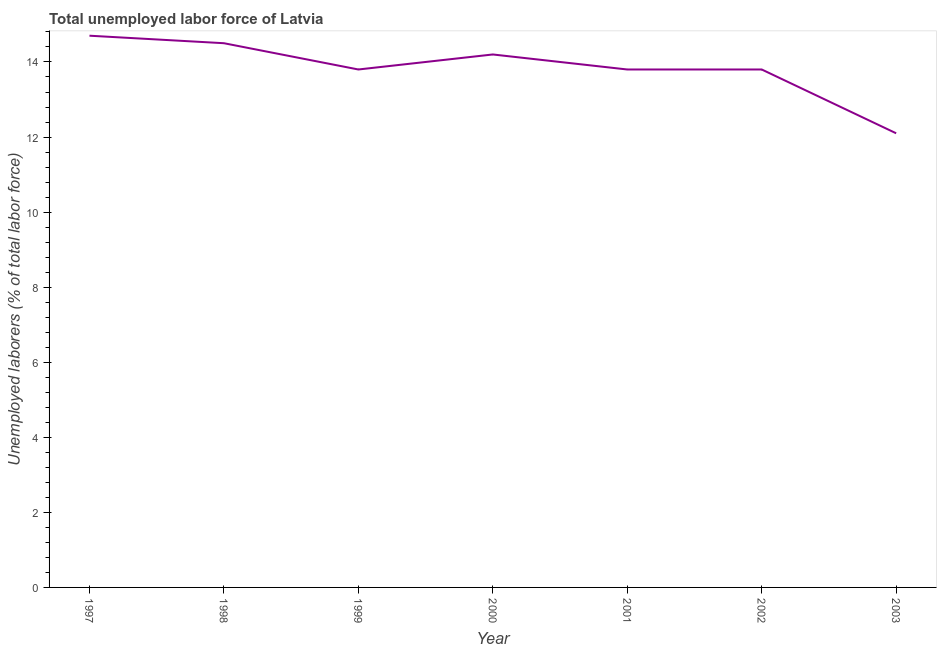What is the total unemployed labour force in 1999?
Give a very brief answer. 13.8. Across all years, what is the maximum total unemployed labour force?
Your answer should be very brief. 14.7. Across all years, what is the minimum total unemployed labour force?
Offer a terse response. 12.1. In which year was the total unemployed labour force minimum?
Your answer should be very brief. 2003. What is the sum of the total unemployed labour force?
Your answer should be very brief. 96.9. What is the difference between the total unemployed labour force in 1998 and 2003?
Offer a very short reply. 2.4. What is the average total unemployed labour force per year?
Provide a short and direct response. 13.84. What is the median total unemployed labour force?
Ensure brevity in your answer.  13.8. In how many years, is the total unemployed labour force greater than 0.4 %?
Keep it short and to the point. 7. Do a majority of the years between 2001 and 2003 (inclusive) have total unemployed labour force greater than 11.2 %?
Give a very brief answer. Yes. What is the ratio of the total unemployed labour force in 1999 to that in 2001?
Your answer should be very brief. 1. Is the total unemployed labour force in 2000 less than that in 2001?
Offer a very short reply. No. Is the difference between the total unemployed labour force in 1998 and 1999 greater than the difference between any two years?
Keep it short and to the point. No. What is the difference between the highest and the second highest total unemployed labour force?
Your response must be concise. 0.2. Is the sum of the total unemployed labour force in 2000 and 2003 greater than the maximum total unemployed labour force across all years?
Your response must be concise. Yes. What is the difference between the highest and the lowest total unemployed labour force?
Keep it short and to the point. 2.6. In how many years, is the total unemployed labour force greater than the average total unemployed labour force taken over all years?
Make the answer very short. 3. How many years are there in the graph?
Your answer should be compact. 7. What is the difference between two consecutive major ticks on the Y-axis?
Offer a terse response. 2. Does the graph contain grids?
Provide a short and direct response. No. What is the title of the graph?
Your answer should be very brief. Total unemployed labor force of Latvia. What is the label or title of the X-axis?
Offer a terse response. Year. What is the label or title of the Y-axis?
Your answer should be compact. Unemployed laborers (% of total labor force). What is the Unemployed laborers (% of total labor force) of 1997?
Offer a terse response. 14.7. What is the Unemployed laborers (% of total labor force) in 1999?
Your answer should be compact. 13.8. What is the Unemployed laborers (% of total labor force) of 2000?
Offer a very short reply. 14.2. What is the Unemployed laborers (% of total labor force) of 2001?
Make the answer very short. 13.8. What is the Unemployed laborers (% of total labor force) of 2002?
Offer a very short reply. 13.8. What is the Unemployed laborers (% of total labor force) in 2003?
Offer a terse response. 12.1. What is the difference between the Unemployed laborers (% of total labor force) in 1997 and 2003?
Offer a terse response. 2.6. What is the difference between the Unemployed laborers (% of total labor force) in 1998 and 1999?
Your answer should be compact. 0.7. What is the difference between the Unemployed laborers (% of total labor force) in 1998 and 2000?
Your answer should be very brief. 0.3. What is the difference between the Unemployed laborers (% of total labor force) in 1998 and 2002?
Your answer should be very brief. 0.7. What is the difference between the Unemployed laborers (% of total labor force) in 1998 and 2003?
Give a very brief answer. 2.4. What is the difference between the Unemployed laborers (% of total labor force) in 1999 and 2003?
Offer a very short reply. 1.7. What is the difference between the Unemployed laborers (% of total labor force) in 2000 and 2001?
Offer a terse response. 0.4. What is the difference between the Unemployed laborers (% of total labor force) in 2000 and 2002?
Offer a very short reply. 0.4. What is the difference between the Unemployed laborers (% of total labor force) in 2002 and 2003?
Ensure brevity in your answer.  1.7. What is the ratio of the Unemployed laborers (% of total labor force) in 1997 to that in 1998?
Give a very brief answer. 1.01. What is the ratio of the Unemployed laborers (% of total labor force) in 1997 to that in 1999?
Keep it short and to the point. 1.06. What is the ratio of the Unemployed laborers (% of total labor force) in 1997 to that in 2000?
Make the answer very short. 1.03. What is the ratio of the Unemployed laborers (% of total labor force) in 1997 to that in 2001?
Your answer should be very brief. 1.06. What is the ratio of the Unemployed laborers (% of total labor force) in 1997 to that in 2002?
Keep it short and to the point. 1.06. What is the ratio of the Unemployed laborers (% of total labor force) in 1997 to that in 2003?
Keep it short and to the point. 1.22. What is the ratio of the Unemployed laborers (% of total labor force) in 1998 to that in 1999?
Make the answer very short. 1.05. What is the ratio of the Unemployed laborers (% of total labor force) in 1998 to that in 2001?
Provide a short and direct response. 1.05. What is the ratio of the Unemployed laborers (% of total labor force) in 1998 to that in 2002?
Provide a short and direct response. 1.05. What is the ratio of the Unemployed laborers (% of total labor force) in 1998 to that in 2003?
Your response must be concise. 1.2. What is the ratio of the Unemployed laborers (% of total labor force) in 1999 to that in 2001?
Offer a very short reply. 1. What is the ratio of the Unemployed laborers (% of total labor force) in 1999 to that in 2003?
Give a very brief answer. 1.14. What is the ratio of the Unemployed laborers (% of total labor force) in 2000 to that in 2001?
Ensure brevity in your answer.  1.03. What is the ratio of the Unemployed laborers (% of total labor force) in 2000 to that in 2003?
Your answer should be very brief. 1.17. What is the ratio of the Unemployed laborers (% of total labor force) in 2001 to that in 2002?
Your response must be concise. 1. What is the ratio of the Unemployed laborers (% of total labor force) in 2001 to that in 2003?
Provide a succinct answer. 1.14. What is the ratio of the Unemployed laborers (% of total labor force) in 2002 to that in 2003?
Your answer should be very brief. 1.14. 